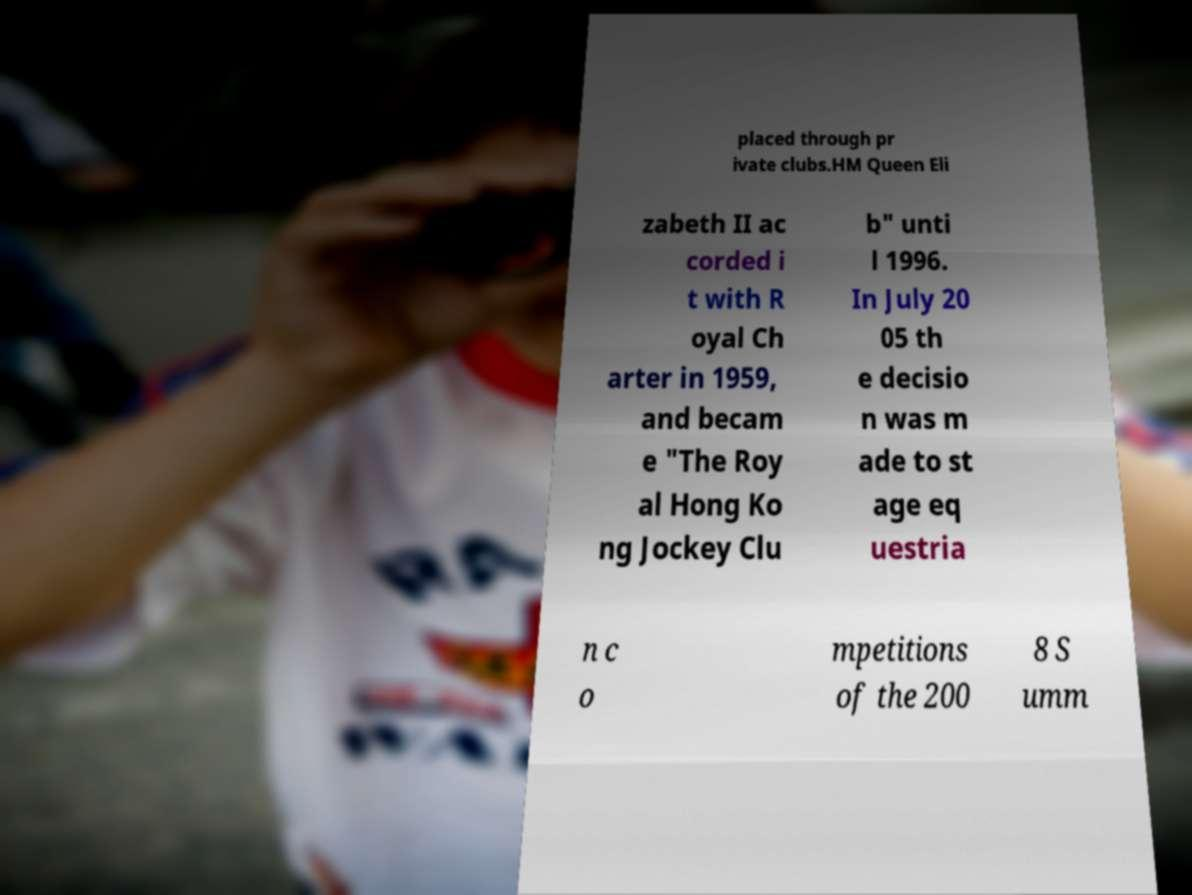Can you accurately transcribe the text from the provided image for me? placed through pr ivate clubs.HM Queen Eli zabeth II ac corded i t with R oyal Ch arter in 1959, and becam e "The Roy al Hong Ko ng Jockey Clu b" unti l 1996. In July 20 05 th e decisio n was m ade to st age eq uestria n c o mpetitions of the 200 8 S umm 